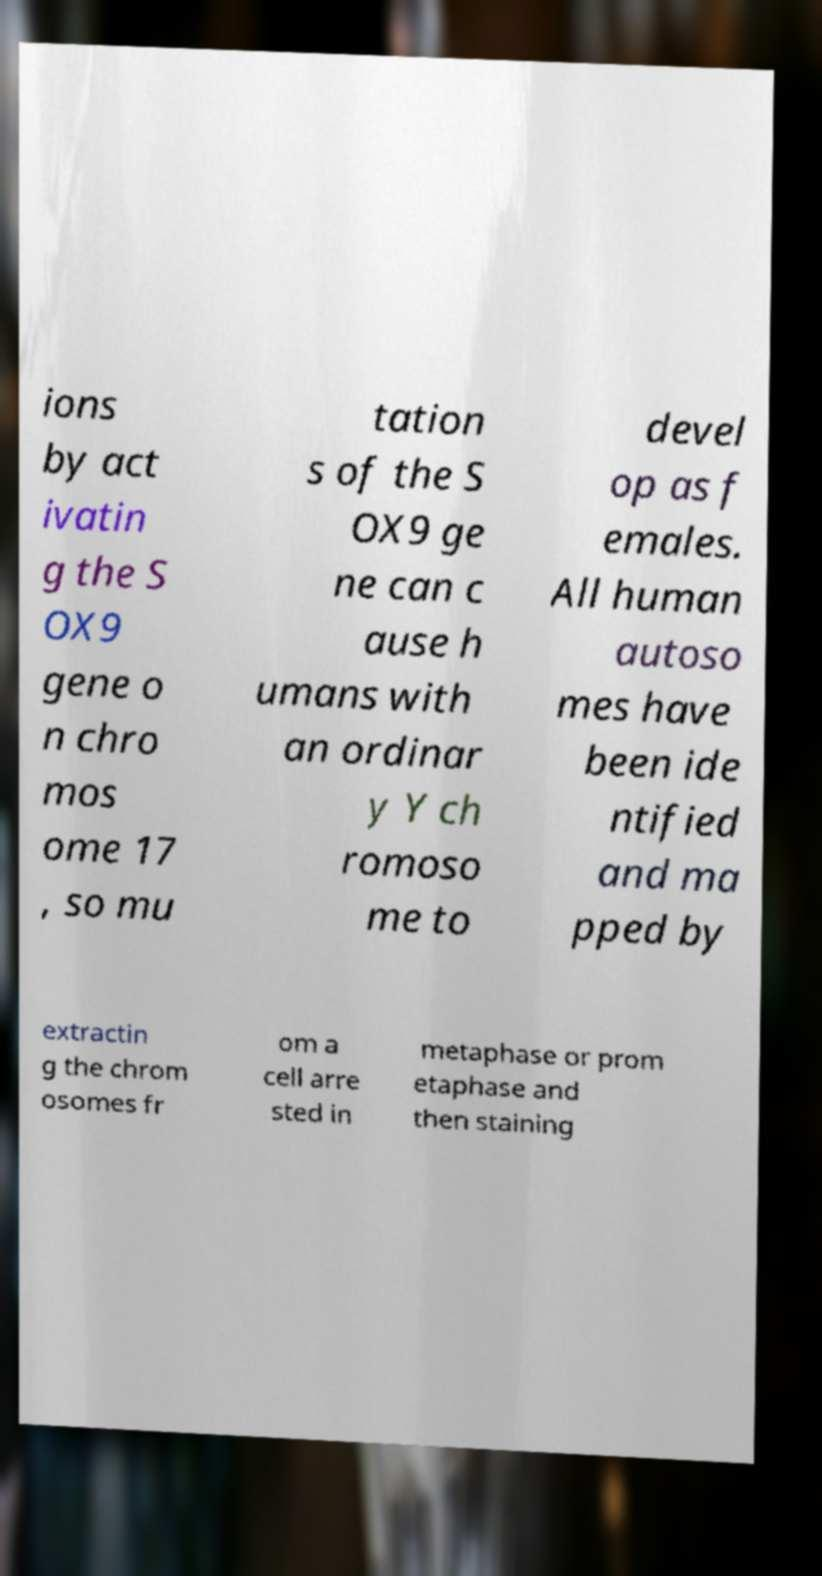Could you extract and type out the text from this image? ions by act ivatin g the S OX9 gene o n chro mos ome 17 , so mu tation s of the S OX9 ge ne can c ause h umans with an ordinar y Y ch romoso me to devel op as f emales. All human autoso mes have been ide ntified and ma pped by extractin g the chrom osomes fr om a cell arre sted in metaphase or prom etaphase and then staining 